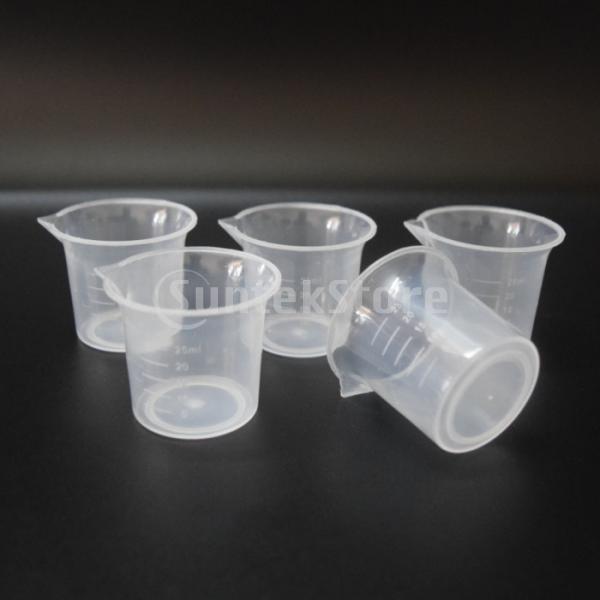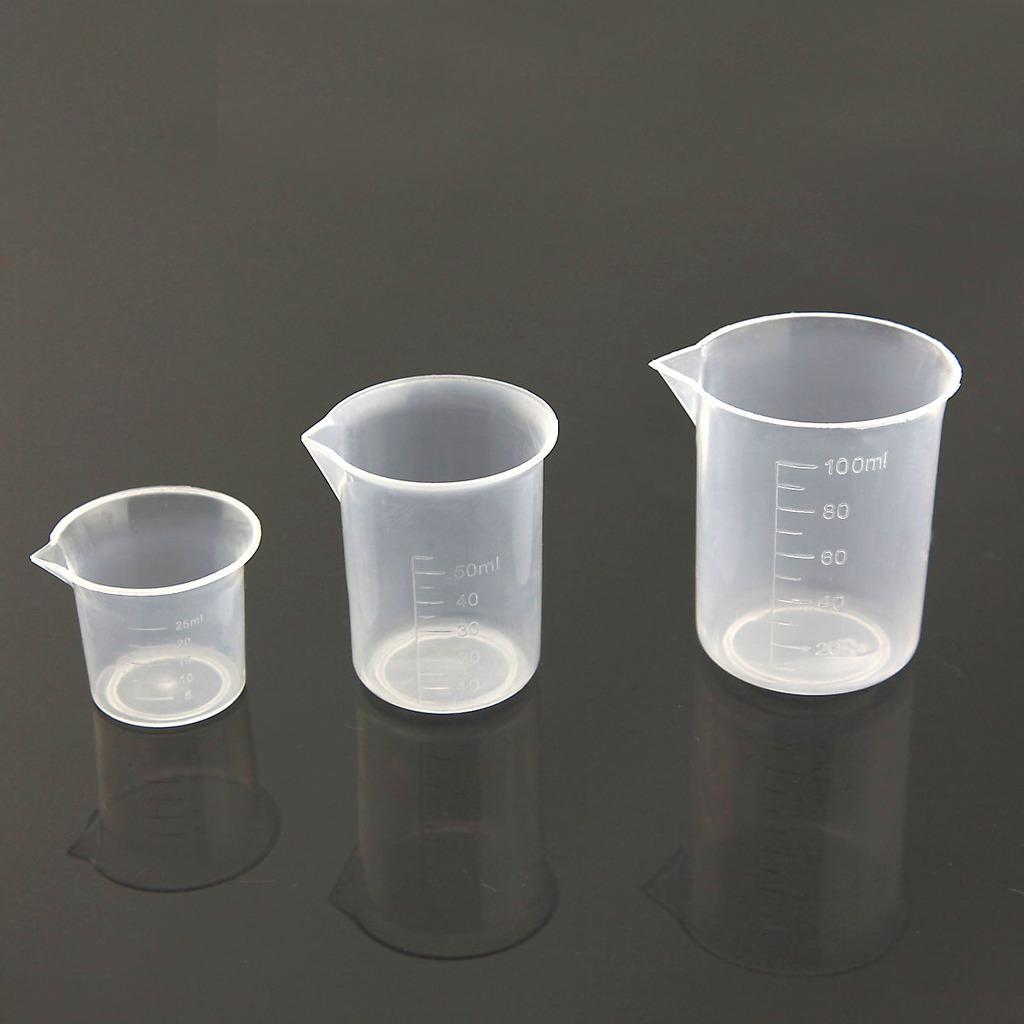The first image is the image on the left, the second image is the image on the right. Analyze the images presented: Is the assertion "One image contains exactly 2 measuring cups." valid? Answer yes or no. No. 